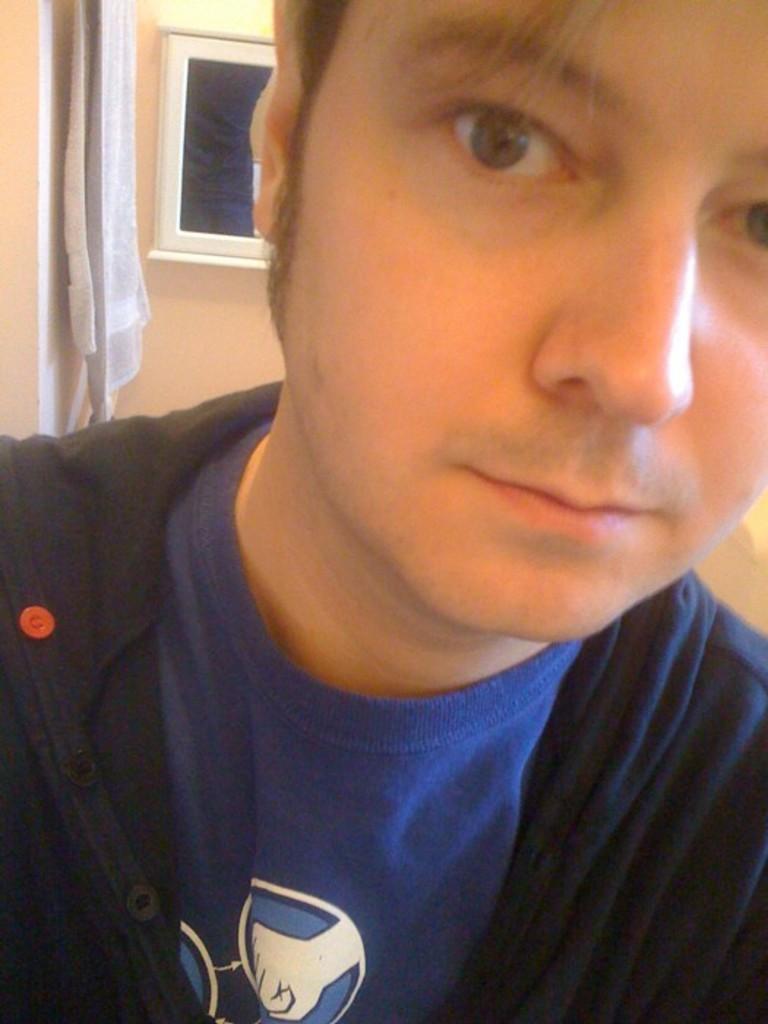Could you give a brief overview of what you see in this image? This is the picture of a room. In this image there is a person with blue t-shirt. At the back there is a device and towel on the wall. 